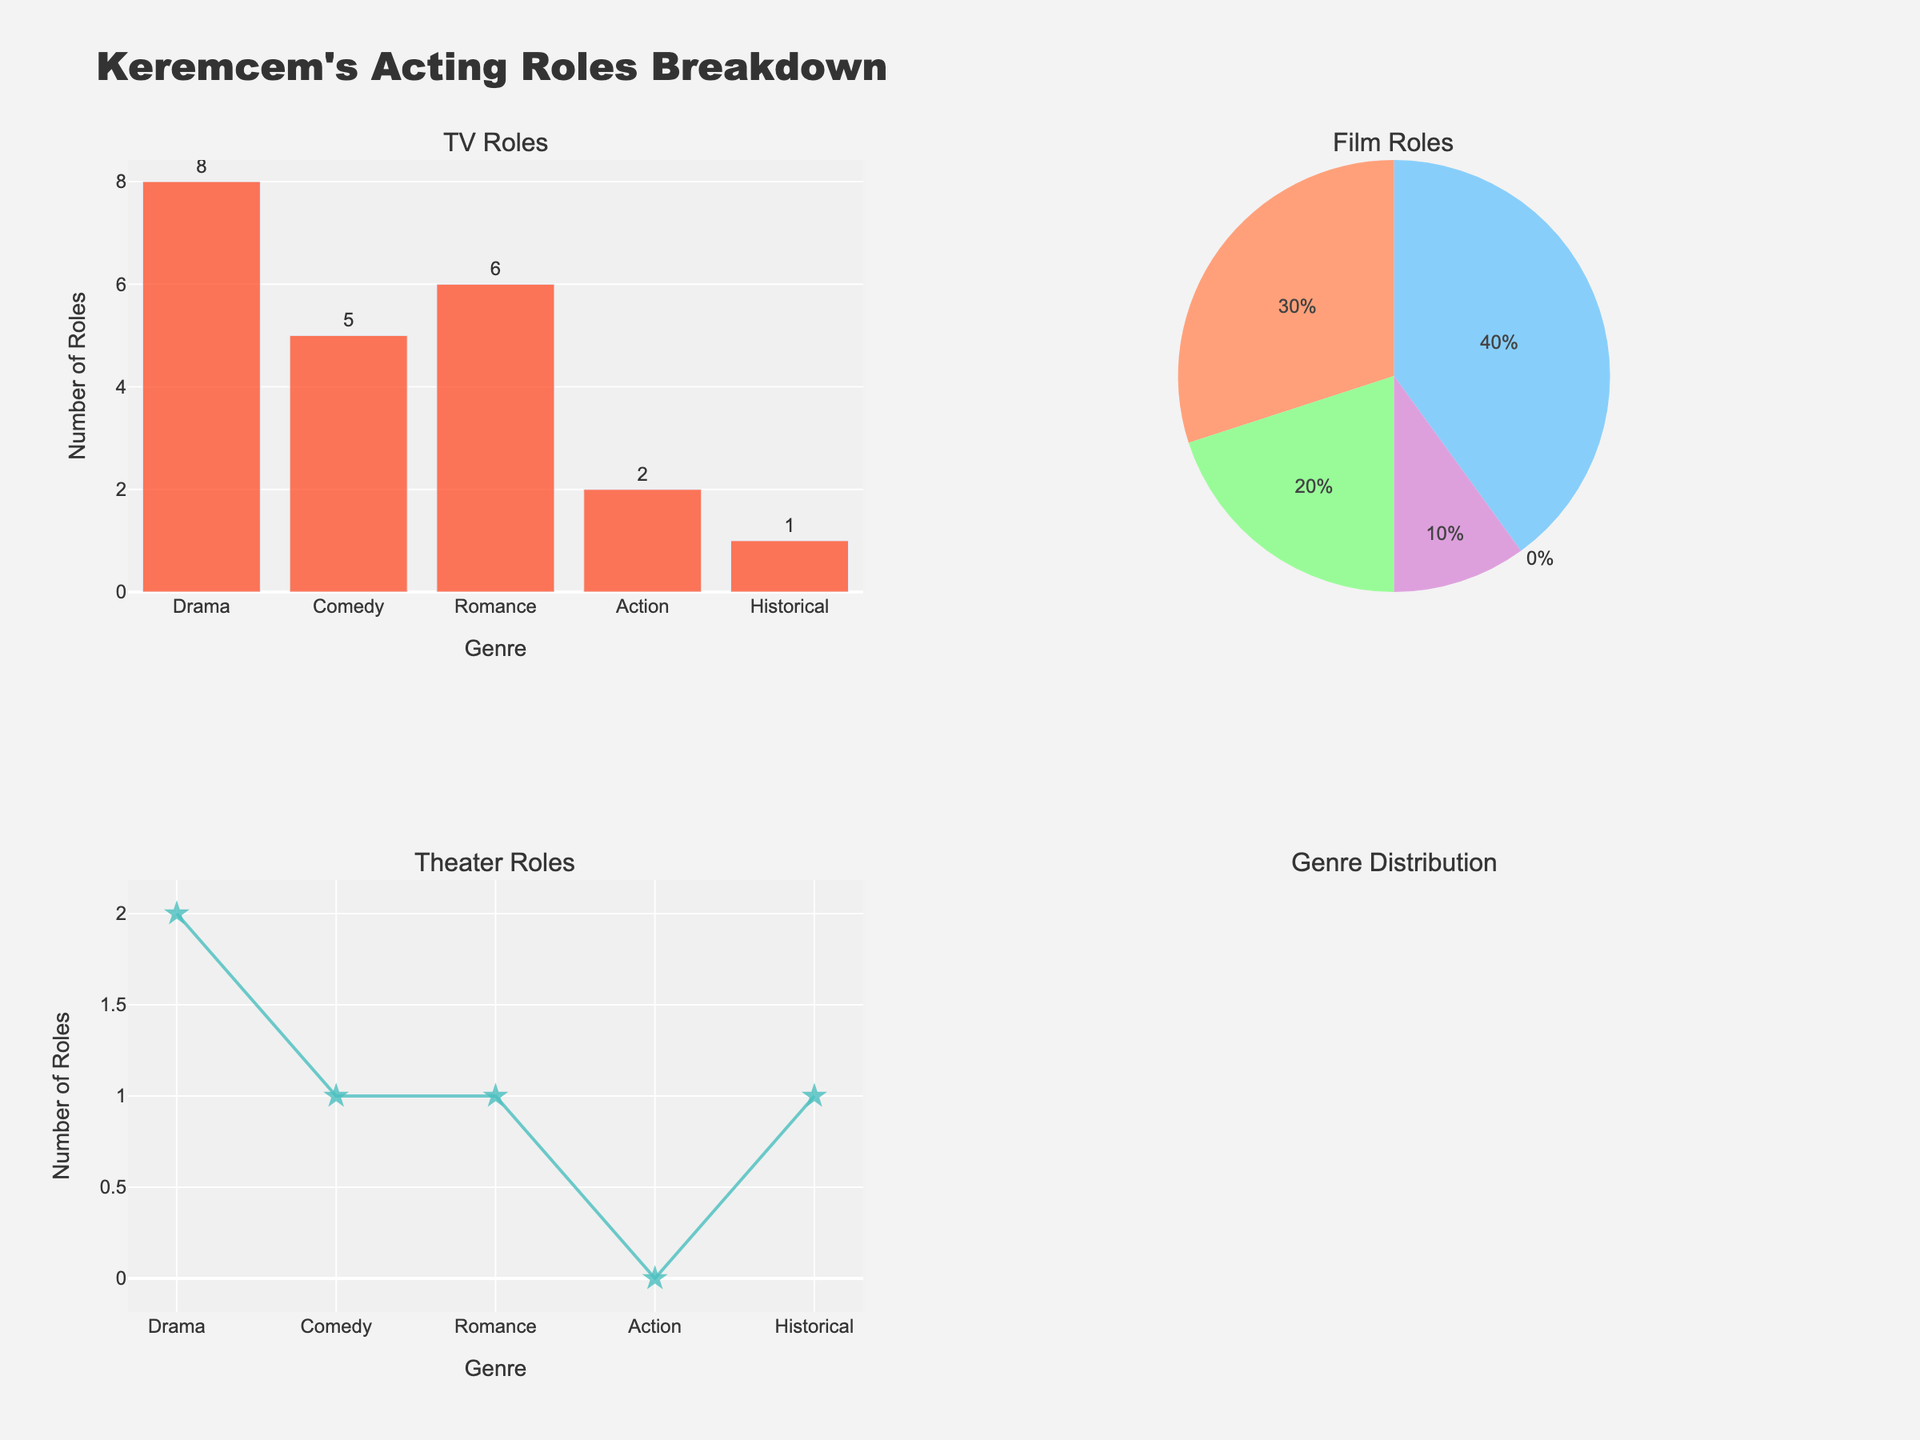What is the title of the figure? The title is located at the top center of the figure. It states "Demographic Analysis of Undercover Operations".
Answer: Demographic Analysis of Undercover Operations Which racial group has the highest representation in "Prostitution Stings"? The bar for White individuals in "Prostitution Stings" reaches 38%, which is higher than any other group in this operation.
Answer: White Which undercover operation targets the highest percentage of Black individuals? By comparing the height of the Black bars across all subplots, "Gang Infiltration" has the highest percentage, at 40%.
Answer: Gang Infiltration Which demographic group has a higher percentage in the general population compared to any undercover operation? By analyzing the subplot for the general population and comparing it to the operations, the White demographic shows 60%, which is higher than its representation in any undercover operation.
Answer: White What is the combined percentage of Hispanic individuals targeted in "Drug Busts" and "Gang Infiltration"? The heights of the bars for Hispanic individuals in "Drug Busts" and "Gang Infiltration" are 20% and 30%, respectively. Adding them gives 20 + 30 = 50%.
Answer: 50% Which operation targets the lowest percentage of Asian individuals? By checking the heights of the Asian bars across all operations, "Drug Busts" and "Gang Infiltration" both show the lowest percentage at 3%.
Answer: Drug Busts and Gang Infiltration In which operation does the "Other" demographic group have the highest representation, aside from the general population? Comparing the "Other" group bars in each operation, "Fraud Investigations" has the highest representation at 3%, aside from the general population which also has 3%.
Answer: Fraud Investigations Is the percentage of Black individuals targeted in "Cybercrime" higher or lower than that in "Prostitution Stings"? The bar for Black individuals in "Cybercrime" is at 15%, whereas in "Prostitution Stings" it is at 35%. Thus, it is lower in "Cybercrime".
Answer: Lower What is the average percentage of White individuals across all undercover operations? The percentages for White individuals in each operation are 45, 38, 25, 55, and 50. Summing these gives 213, and dividing by the number of operations (5) gives 213 / 5 = 42.6%.
Answer: 42.6% Which demographic group shows the least variability in percentage across the operations, judging by the bars' heights? The "Other" demographic group has percentages of 2, 1, 2, 2, and 3 across the different operations, indicating smaller differences than other demographic groups.
Answer: Other 